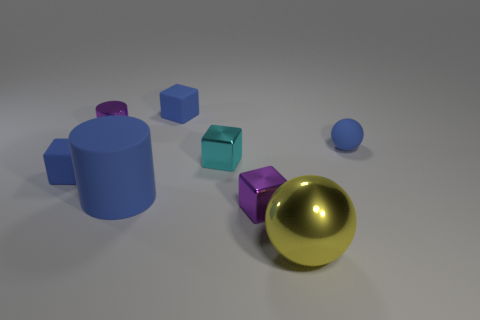Add 2 big blue cylinders. How many objects exist? 10 Subtract all tiny purple shiny cubes. How many cubes are left? 3 Subtract all cyan cylinders. How many blue cubes are left? 2 Subtract all blue cubes. How many cubes are left? 2 Subtract all cylinders. How many objects are left? 6 Subtract 2 cubes. How many cubes are left? 2 Subtract all yellow things. Subtract all purple metallic blocks. How many objects are left? 6 Add 7 blue blocks. How many blue blocks are left? 9 Add 3 small purple metal blocks. How many small purple metal blocks exist? 4 Subtract 0 green cubes. How many objects are left? 8 